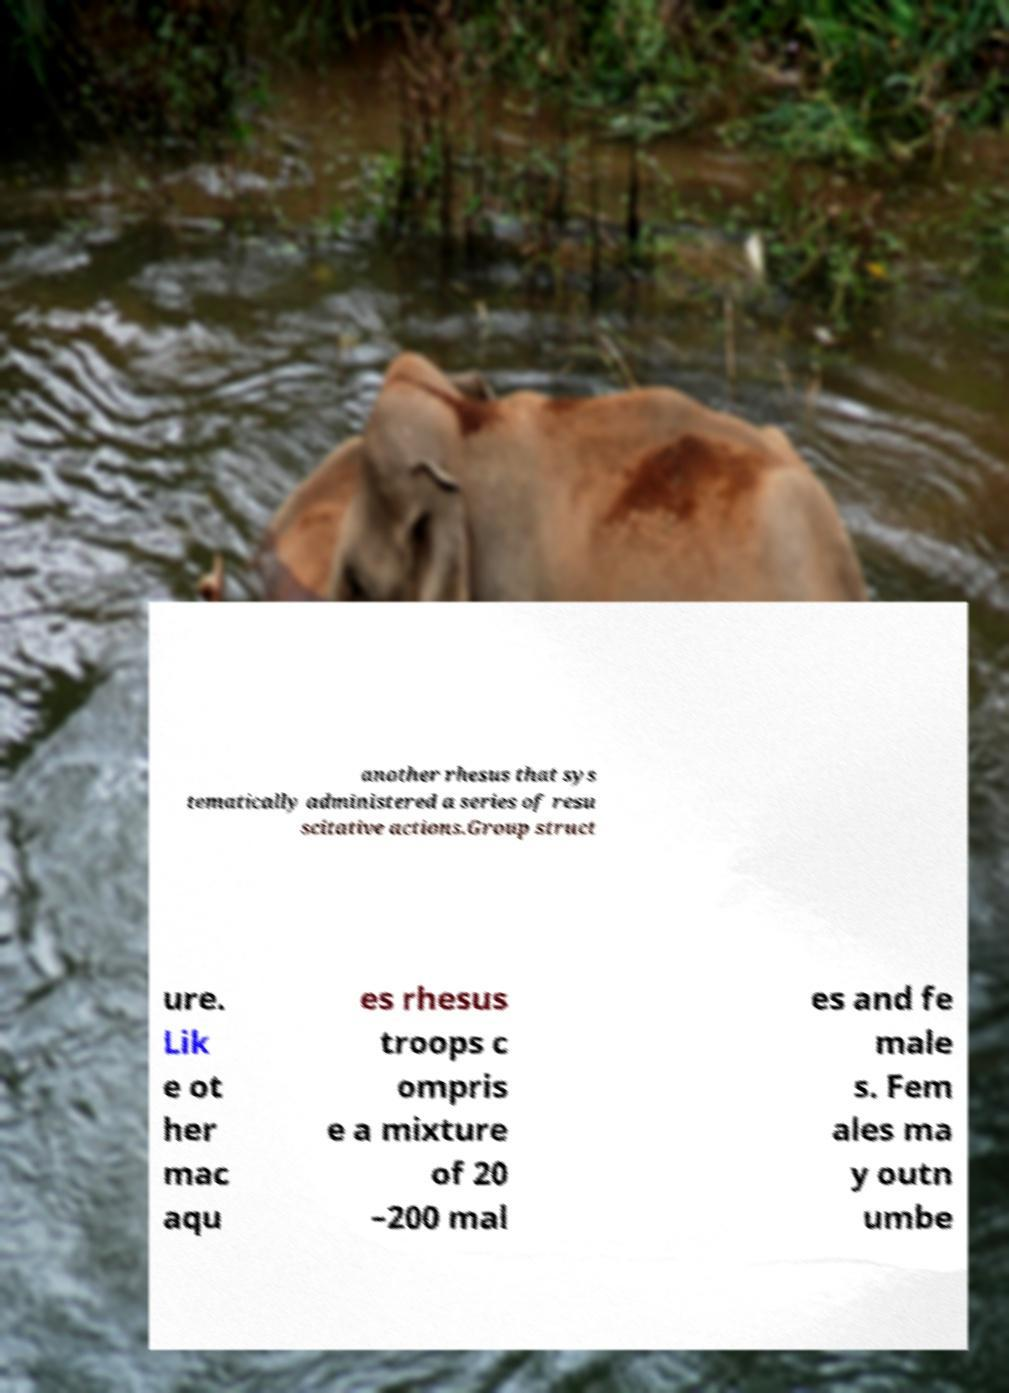Could you assist in decoding the text presented in this image and type it out clearly? another rhesus that sys tematically administered a series of resu scitative actions.Group struct ure. Lik e ot her mac aqu es rhesus troops c ompris e a mixture of 20 –200 mal es and fe male s. Fem ales ma y outn umbe 